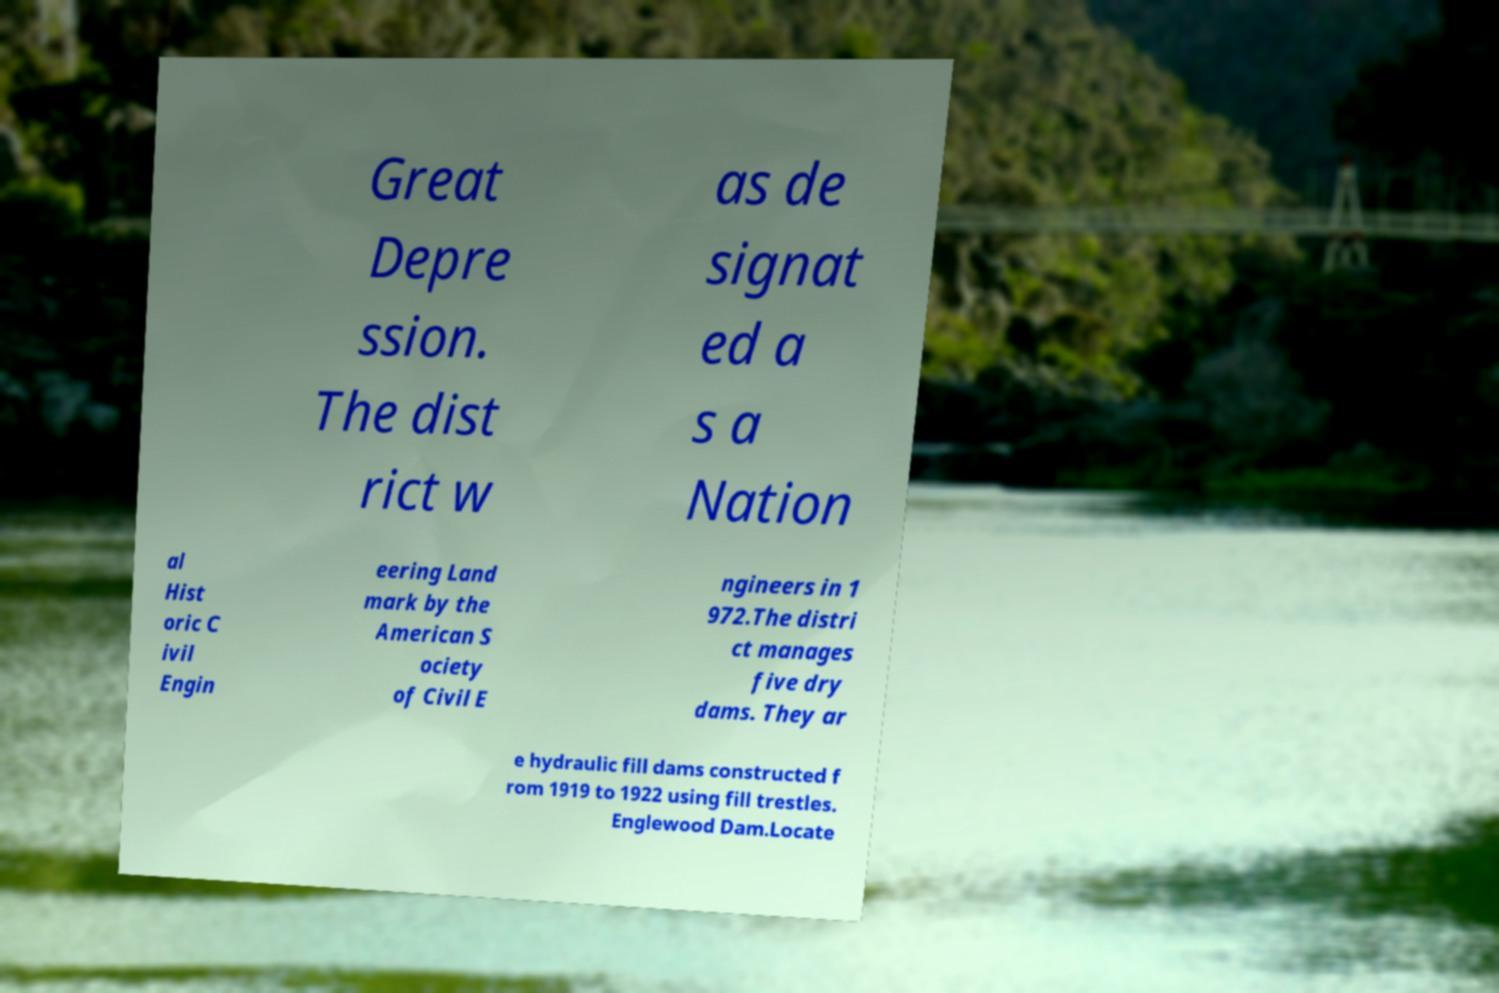Could you extract and type out the text from this image? Great Depre ssion. The dist rict w as de signat ed a s a Nation al Hist oric C ivil Engin eering Land mark by the American S ociety of Civil E ngineers in 1 972.The distri ct manages five dry dams. They ar e hydraulic fill dams constructed f rom 1919 to 1922 using fill trestles. Englewood Dam.Locate 